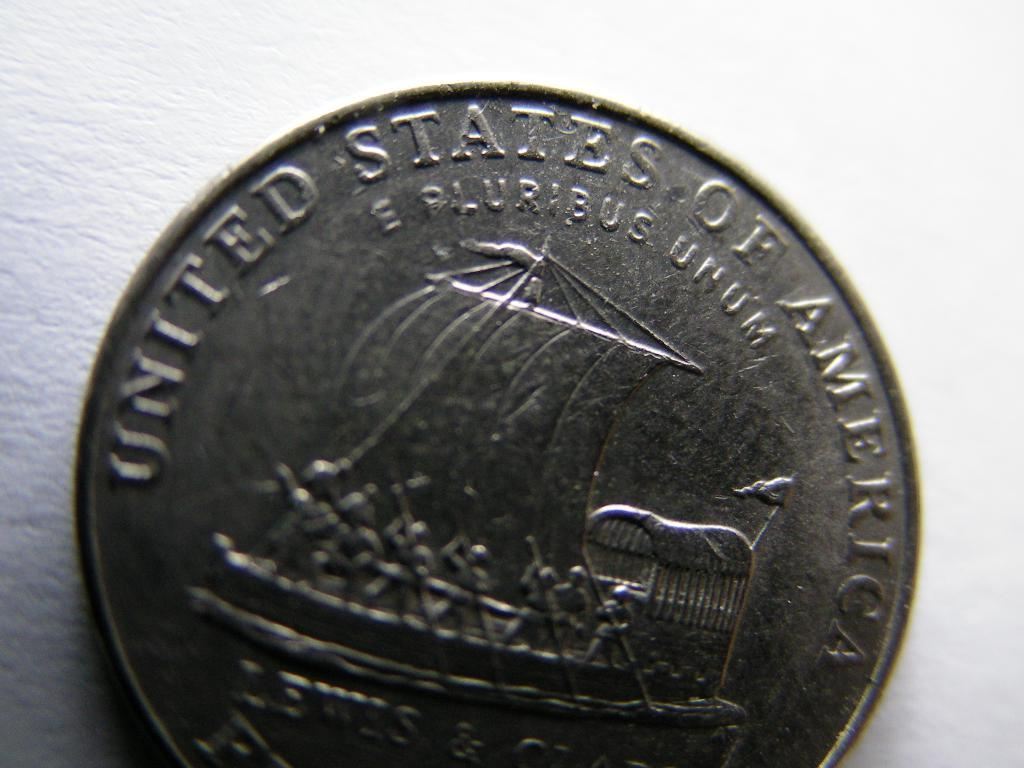<image>
Summarize the visual content of the image. A silver coin from the United States of America that has a boat engraved on it. 